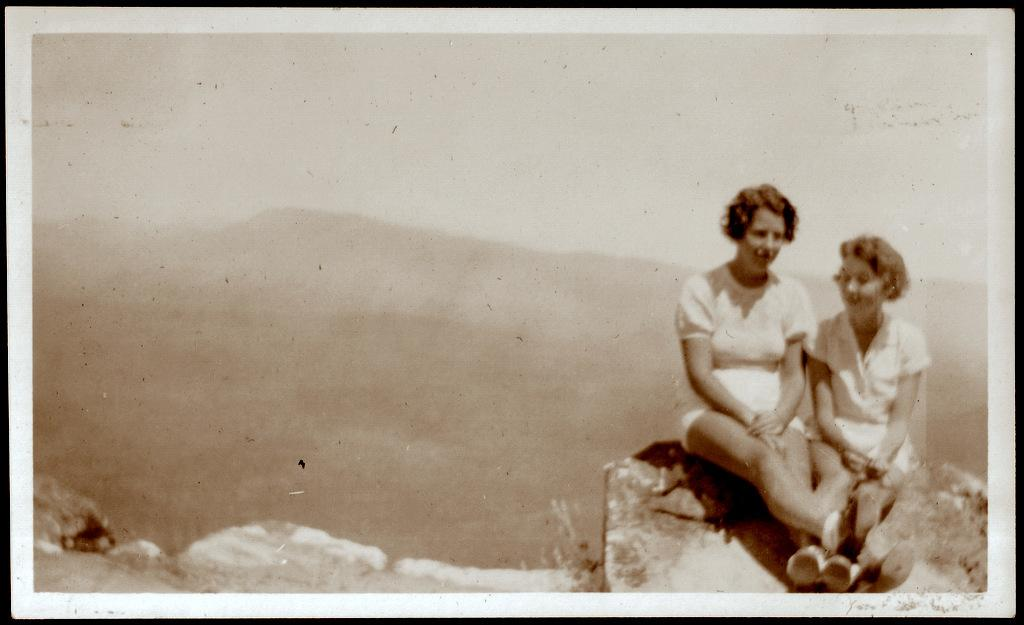How many people are in the image? There are two people in the image. What are the two people doing in the image? The two people are sitting on a rock. What type of magic is the beginner practicing in the image? There is no magic or beginner present in the image; it simply shows two people sitting on a rock. 